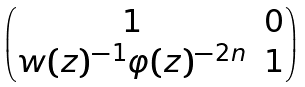<formula> <loc_0><loc_0><loc_500><loc_500>\begin{pmatrix} 1 & 0 \\ w ( z ) ^ { - 1 } \varphi ( z ) ^ { - 2 n } & 1 \end{pmatrix}</formula> 